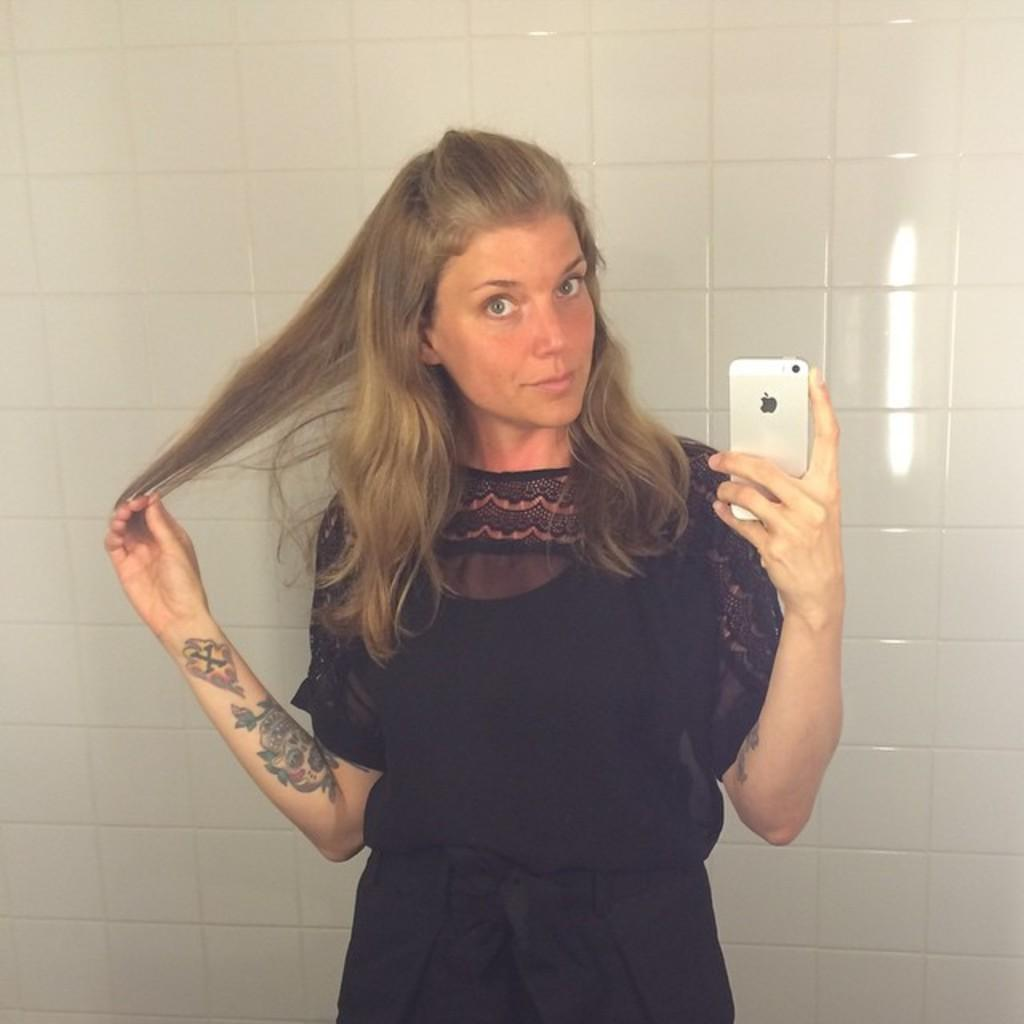What is the main subject of the picture? The main subject of the picture is a woman. What is the woman doing in the picture? The woman is standing in the picture. What object is the woman holding? The woman is holding a phone. What can be observed about the woman's appearance? The woman has hair, and there is a tattoo on her right hand. What can be seen in the background of the picture? There are tiles on the wall in the background. What type of potato is visible on the woman's collar in the image? There is no potato or collar present in the image. 